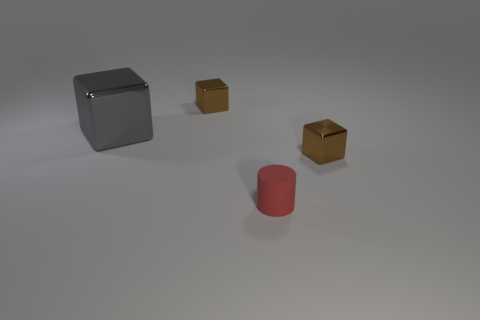Is there anything else that has the same size as the gray thing?
Keep it short and to the point. No. What number of objects are big gray metallic cubes or shiny blocks right of the large gray block?
Provide a short and direct response. 3. Is there a cyan cylinder?
Ensure brevity in your answer.  No. What is the size of the brown block right of the tiny brown thing that is on the left side of the tiny red rubber object?
Give a very brief answer. Small. Is there a cylinder made of the same material as the large gray object?
Your answer should be very brief. No. Do the small cube to the left of the tiny cylinder and the shiny thing to the right of the red cylinder have the same color?
Your answer should be very brief. Yes. Are there any brown objects in front of the small brown block on the left side of the tiny matte cylinder?
Your answer should be very brief. Yes. There is a tiny shiny thing to the left of the cylinder; does it have the same shape as the tiny brown shiny object that is in front of the large metal cube?
Offer a terse response. Yes. Is the brown object on the left side of the cylinder made of the same material as the block that is in front of the large gray block?
Keep it short and to the point. Yes. There is a cube that is to the right of the brown metallic block behind the large object; what is its material?
Your answer should be compact. Metal. 